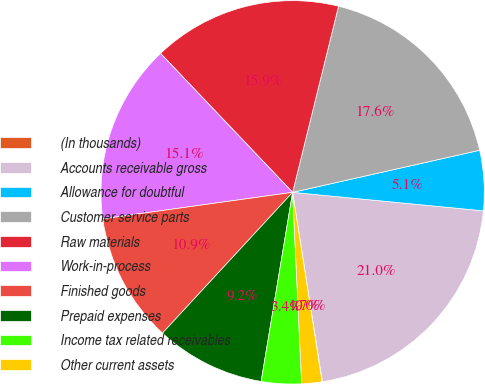Convert chart to OTSL. <chart><loc_0><loc_0><loc_500><loc_500><pie_chart><fcel>(In thousands)<fcel>Accounts receivable gross<fcel>Allowance for doubtful<fcel>Customer service parts<fcel>Raw materials<fcel>Work-in-process<fcel>Finished goods<fcel>Prepaid expenses<fcel>Income tax related receivables<fcel>Other current assets<nl><fcel>0.03%<fcel>20.98%<fcel>5.06%<fcel>17.63%<fcel>15.95%<fcel>15.11%<fcel>10.92%<fcel>9.25%<fcel>3.38%<fcel>1.7%<nl></chart> 